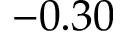<formula> <loc_0><loc_0><loc_500><loc_500>- 0 . 3 0</formula> 